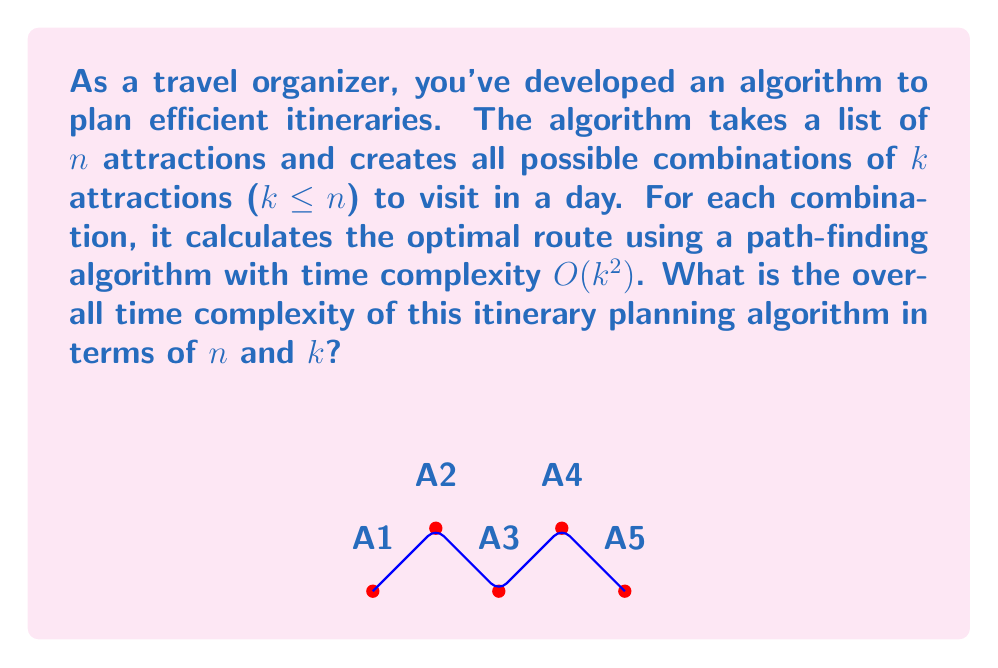Give your solution to this math problem. Let's analyze the algorithm step by step:

1) First, we need to calculate the number of combinations of $k$ attractions from $n$ total attractions. This is given by the combination formula:

   $$\binom{n}{k} = \frac{n!}{k!(n-k)!}$$

2) For each combination, we run a path-finding algorithm with time complexity $O(k^2)$.

3) Therefore, the total time complexity is:

   $$O\left(\binom{n}{k} \cdot k^2\right)$$

4) We can simplify this further. The upper bound for $\binom{n}{k}$ is $n^k$ when $k \leq n/2$. So, we can say:

   $$O\left(\binom{n}{k} \cdot k^2\right) \leq O(n^k \cdot k^2)$$

5) This can be written as:

   $$O(n^k \cdot k^2)$$

This is the overall time complexity of the algorithm. Note that this is an exponential time complexity with respect to $k$, which means the algorithm becomes very slow for large values of $k$.
Answer: $O(n^k \cdot k^2)$ 